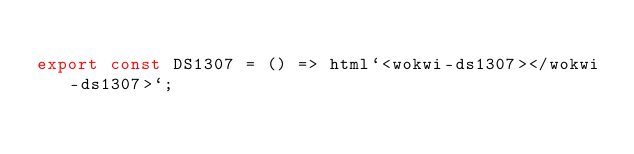Convert code to text. <code><loc_0><loc_0><loc_500><loc_500><_TypeScript_>
export const DS1307 = () => html`<wokwi-ds1307></wokwi-ds1307>`;
</code> 